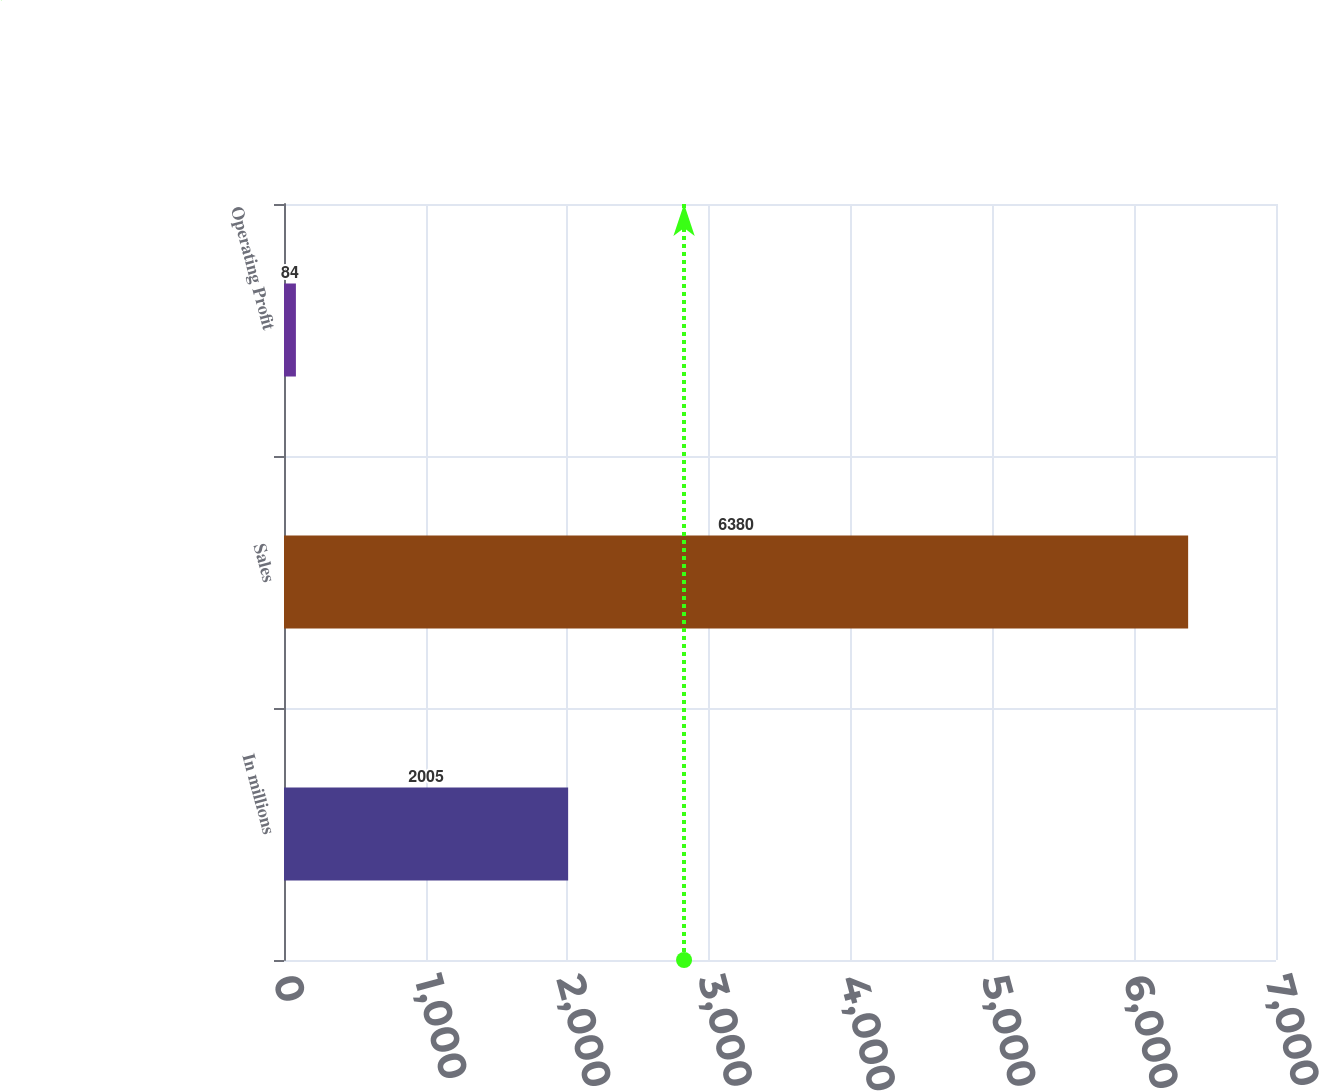Convert chart. <chart><loc_0><loc_0><loc_500><loc_500><bar_chart><fcel>In millions<fcel>Sales<fcel>Operating Profit<nl><fcel>2005<fcel>6380<fcel>84<nl></chart> 